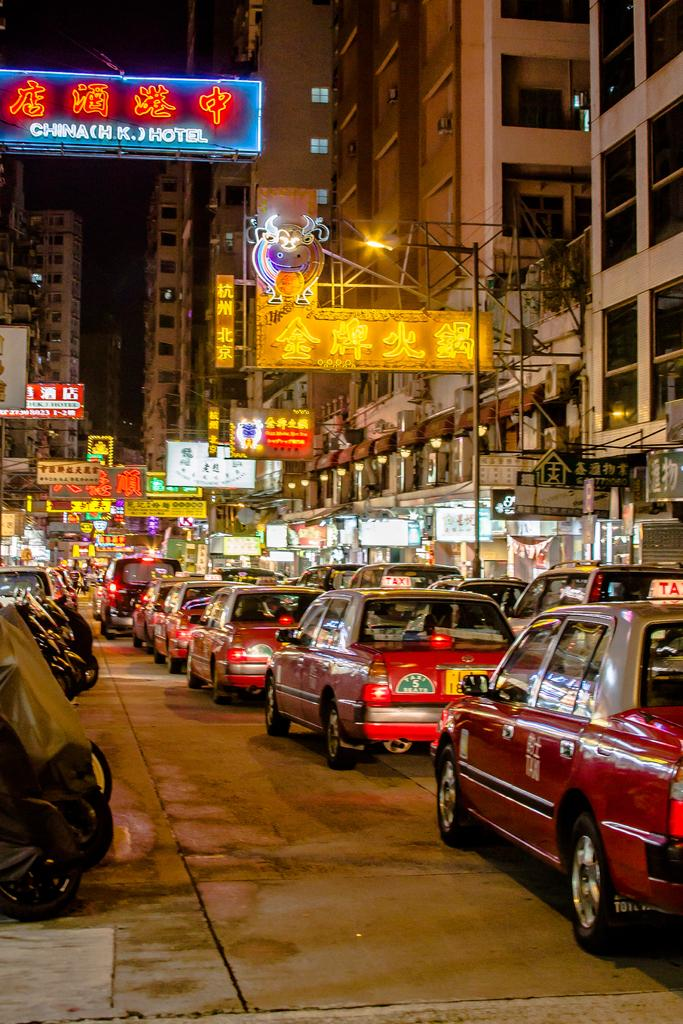<image>
Share a concise interpretation of the image provided. Red taxis fill the street with hotel and other signs in neon lights. 